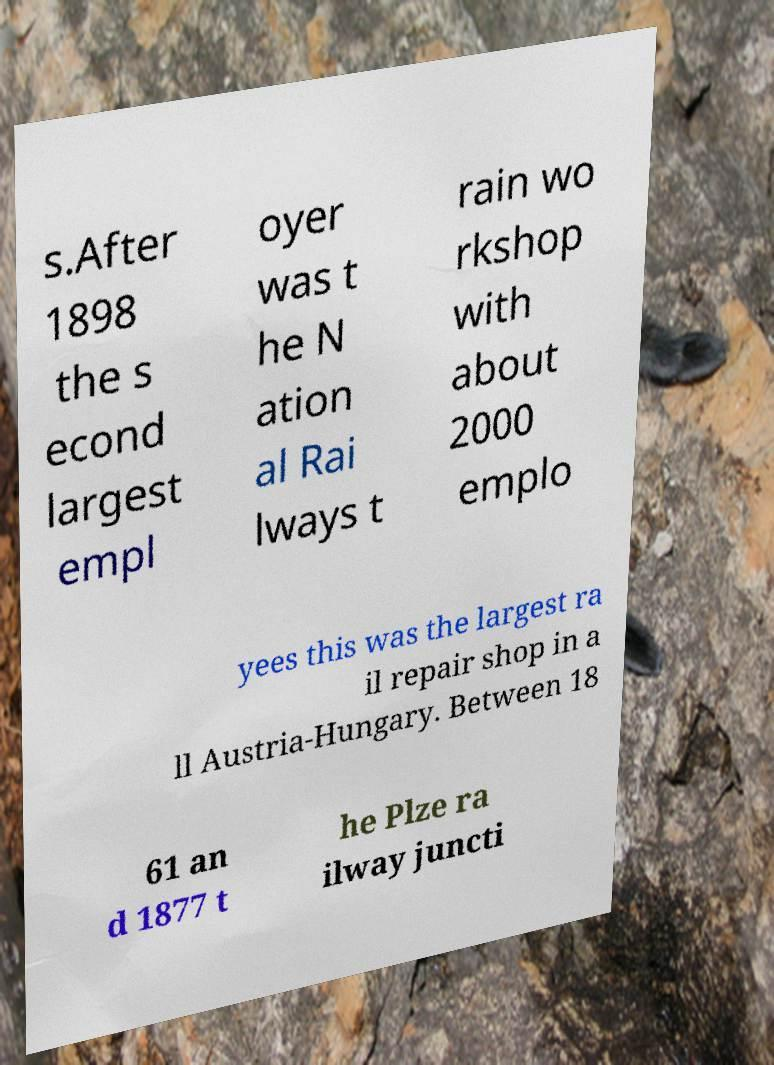Could you assist in decoding the text presented in this image and type it out clearly? s.After 1898 the s econd largest empl oyer was t he N ation al Rai lways t rain wo rkshop with about 2000 emplo yees this was the largest ra il repair shop in a ll Austria-Hungary. Between 18 61 an d 1877 t he Plze ra ilway juncti 